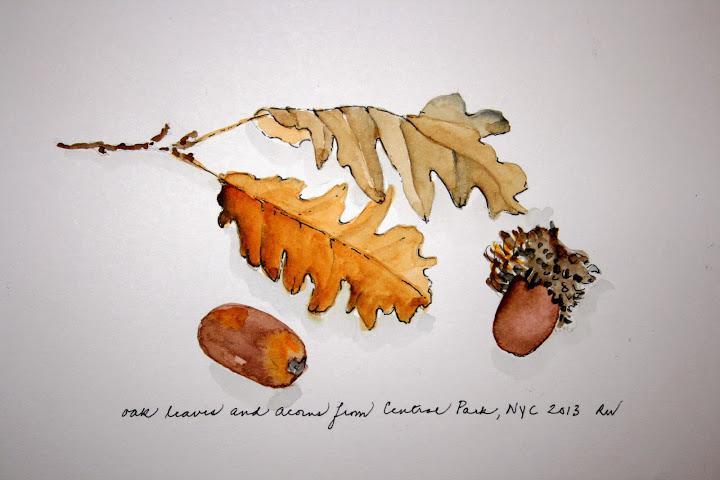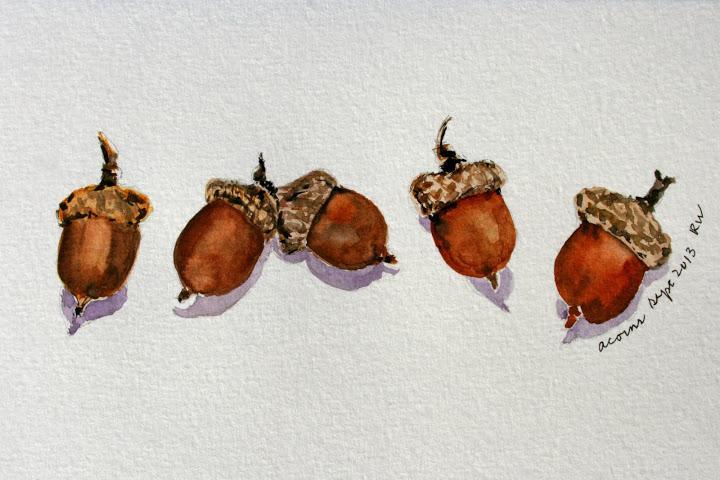The first image is the image on the left, the second image is the image on the right. Evaluate the accuracy of this statement regarding the images: "The left image includes two brown acorns, and at least one oak leaf on a stem above them.". Is it true? Answer yes or no. Yes. The first image is the image on the left, the second image is the image on the right. Evaluate the accuracy of this statement regarding the images: "There are exactly two acorns in the left image.". Is it true? Answer yes or no. Yes. 